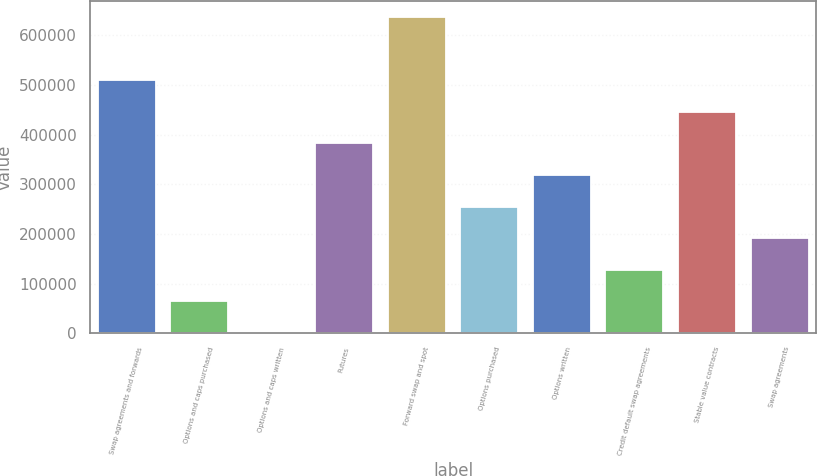Convert chart to OTSL. <chart><loc_0><loc_0><loc_500><loc_500><bar_chart><fcel>Swap agreements and forwards<fcel>Options and caps purchased<fcel>Options and caps written<fcel>Futures<fcel>Forward swap and spot<fcel>Options purchased<fcel>Options written<fcel>Credit default swap agreements<fcel>Stable value contracts<fcel>Swap agreements<nl><fcel>510304<fcel>63901.7<fcel>130<fcel>382760<fcel>637847<fcel>255217<fcel>318988<fcel>127673<fcel>446532<fcel>191445<nl></chart> 